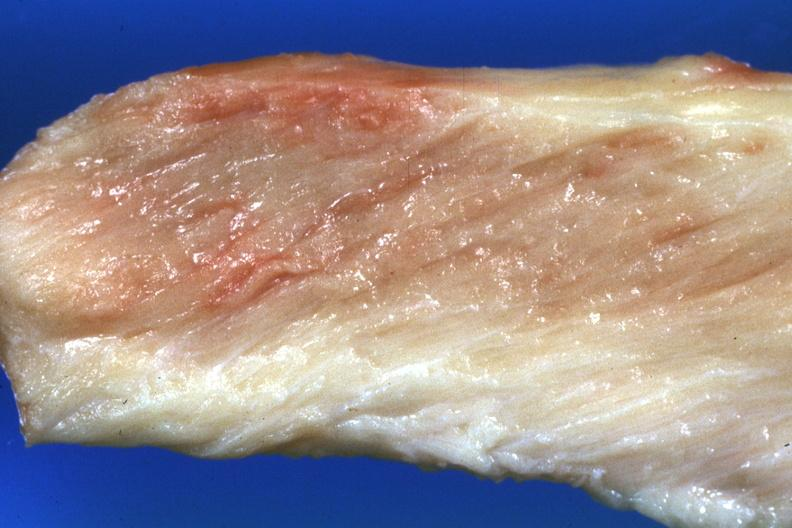s quite good liver present?
Answer the question using a single word or phrase. No 